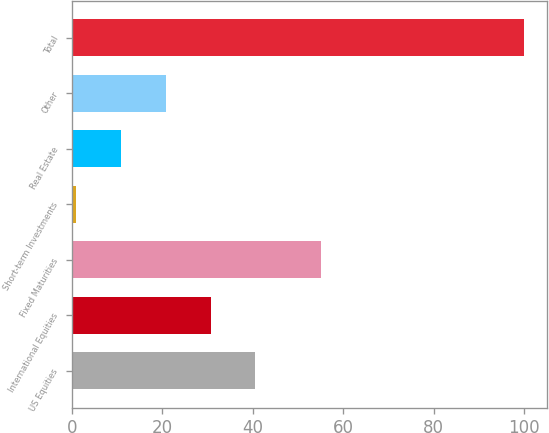<chart> <loc_0><loc_0><loc_500><loc_500><bar_chart><fcel>US Equities<fcel>International Equities<fcel>Fixed Maturities<fcel>Short-term Investments<fcel>Real Estate<fcel>Other<fcel>Total<nl><fcel>40.6<fcel>30.7<fcel>55<fcel>1<fcel>10.9<fcel>20.8<fcel>100<nl></chart> 